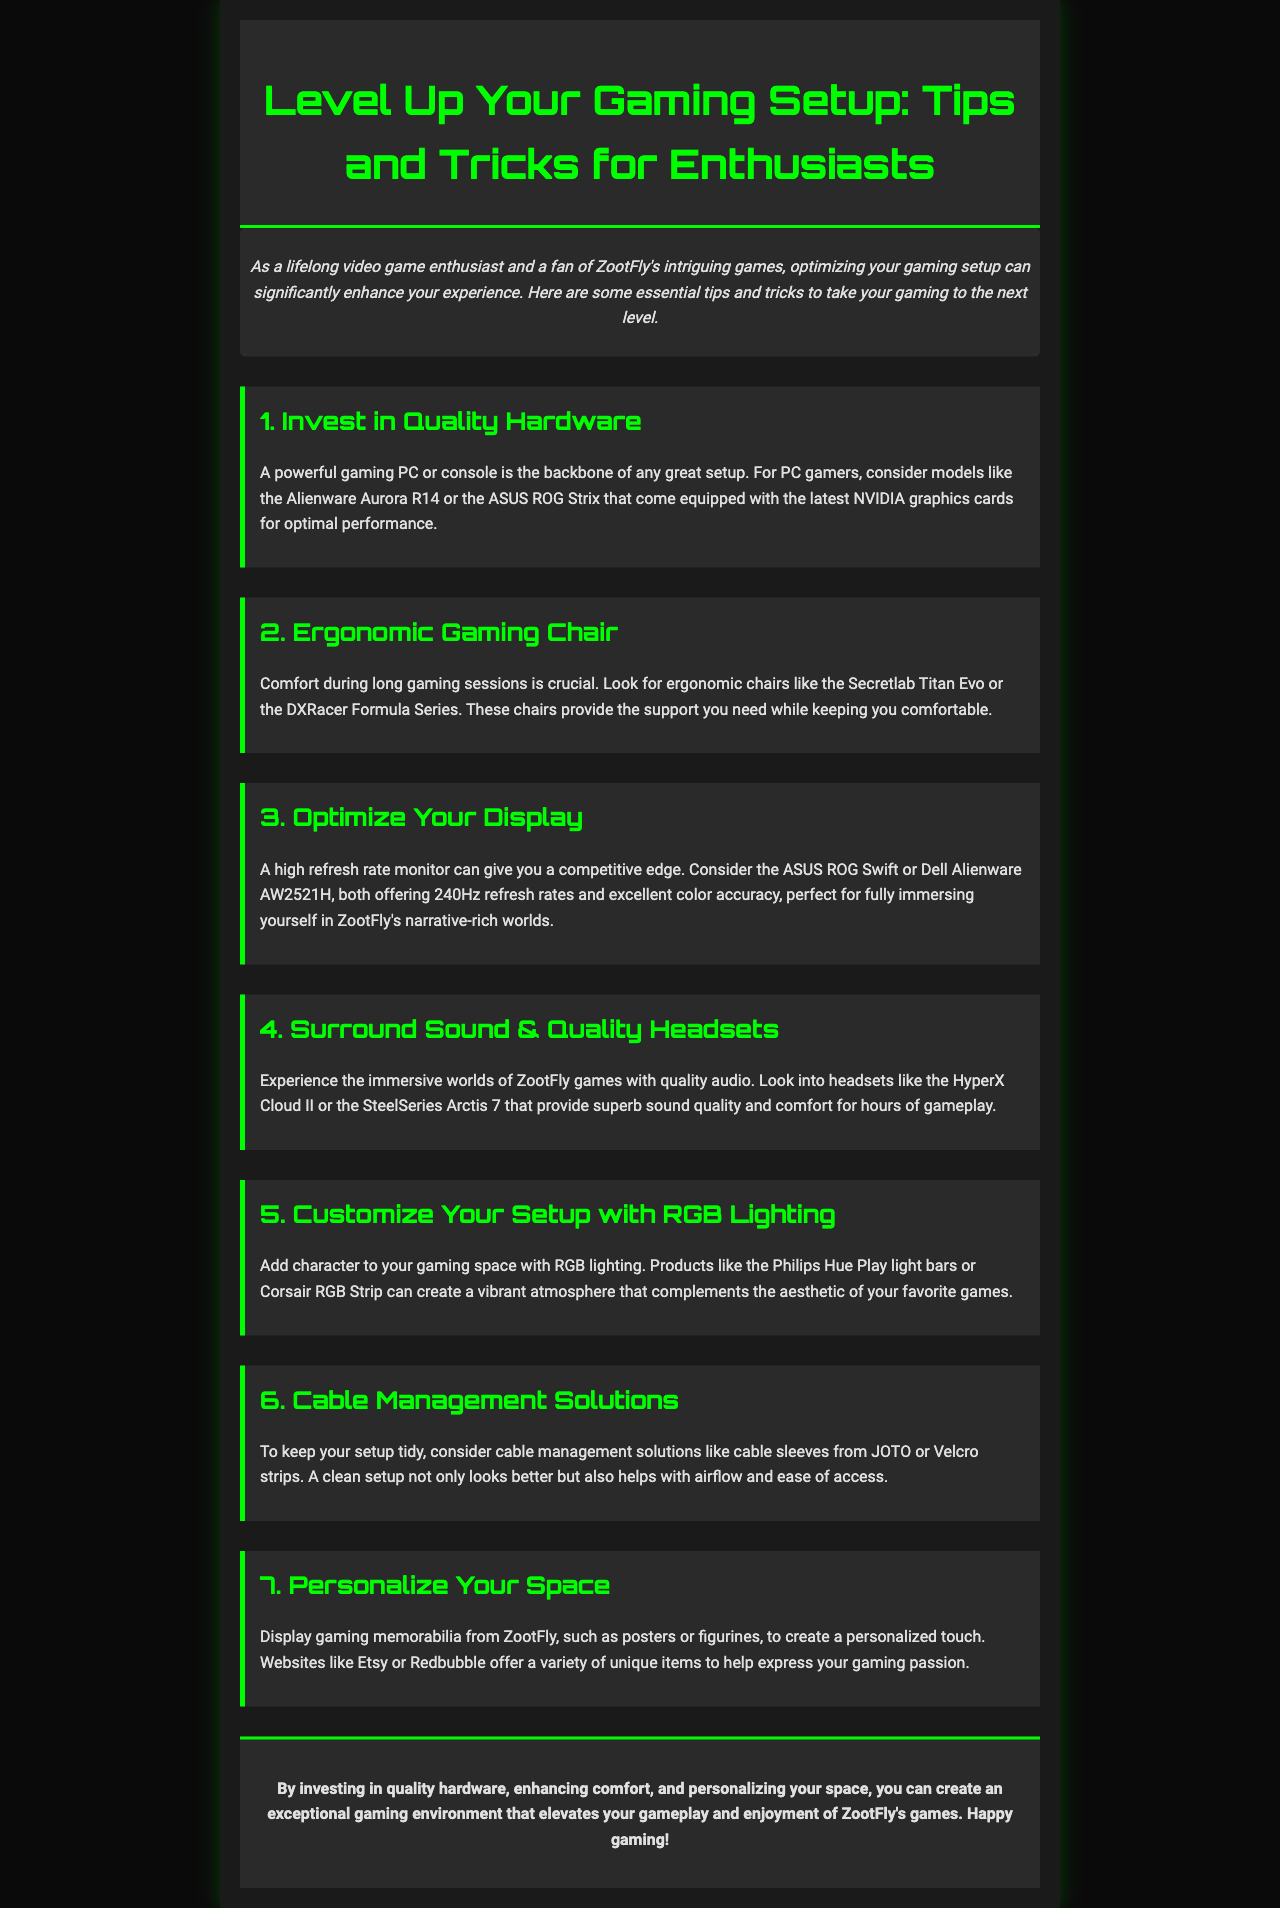What is the title of the newsletter? The title of the newsletter is prominently displayed at the top of the document, indicating the main focus.
Answer: Level Up Your Gaming Setup: Tips and Tricks for Enthusiasts What is one example of a quality gaming chair recommended in the document? The document lists specific products to enhance your gaming setup, such as ergonomic chairs for comfort.
Answer: Secretlab Titan Evo Which monitor refresh rate is mentioned as beneficial for gaming? The document mentions refresh rates that can enhance gaming performance, particularly for competitive gaming.
Answer: 240Hz What lighting solution does the document suggest for personalizing a gaming setup? The newsletter recommends products that add character and ambiance to the gaming environment.
Answer: Philips Hue Play light bars Why is cable management important according to the document? The document explains reasons for maintaining a tidy setup, emphasizing practical benefits for gamers.
Answer: Airflow and ease of access What does the conclusion recommend for enjoying ZootFly games? The conclusion summarizes the key improvements to enhance the gaming experience specifically related to ZootFly titles.
Answer: Quality hardware, enhancing comfort, and personalizing your space 